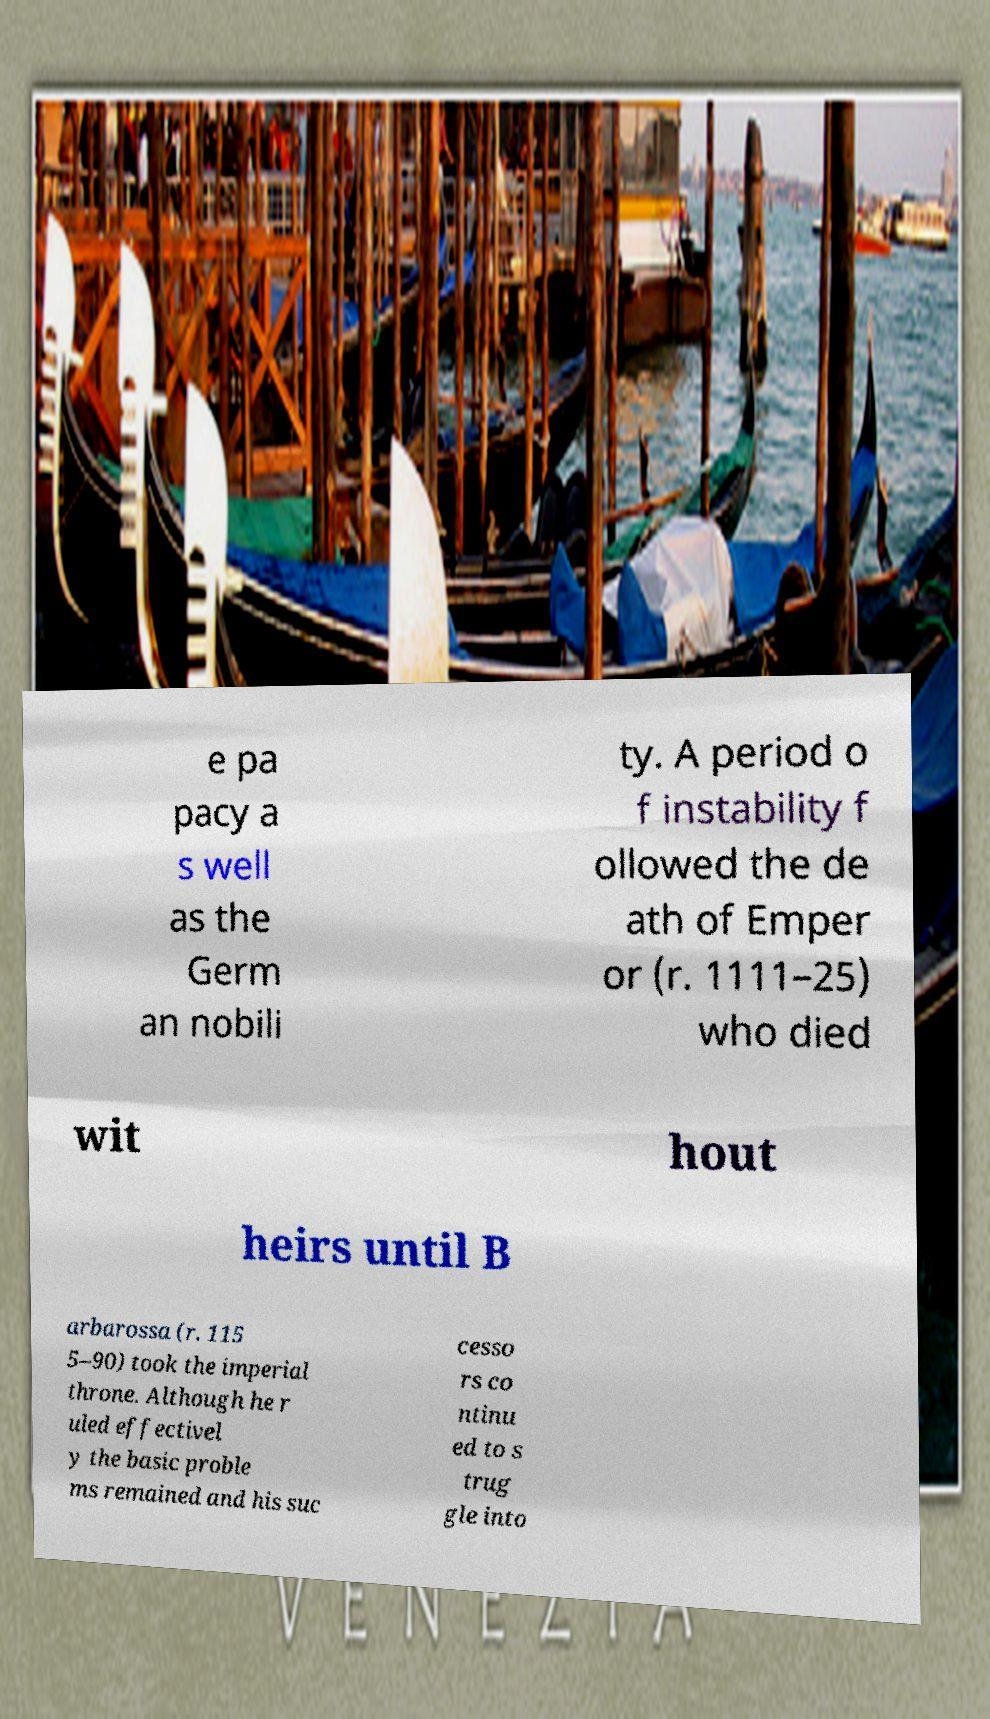I need the written content from this picture converted into text. Can you do that? e pa pacy a s well as the Germ an nobili ty. A period o f instability f ollowed the de ath of Emper or (r. 1111–25) who died wit hout heirs until B arbarossa (r. 115 5–90) took the imperial throne. Although he r uled effectivel y the basic proble ms remained and his suc cesso rs co ntinu ed to s trug gle into 